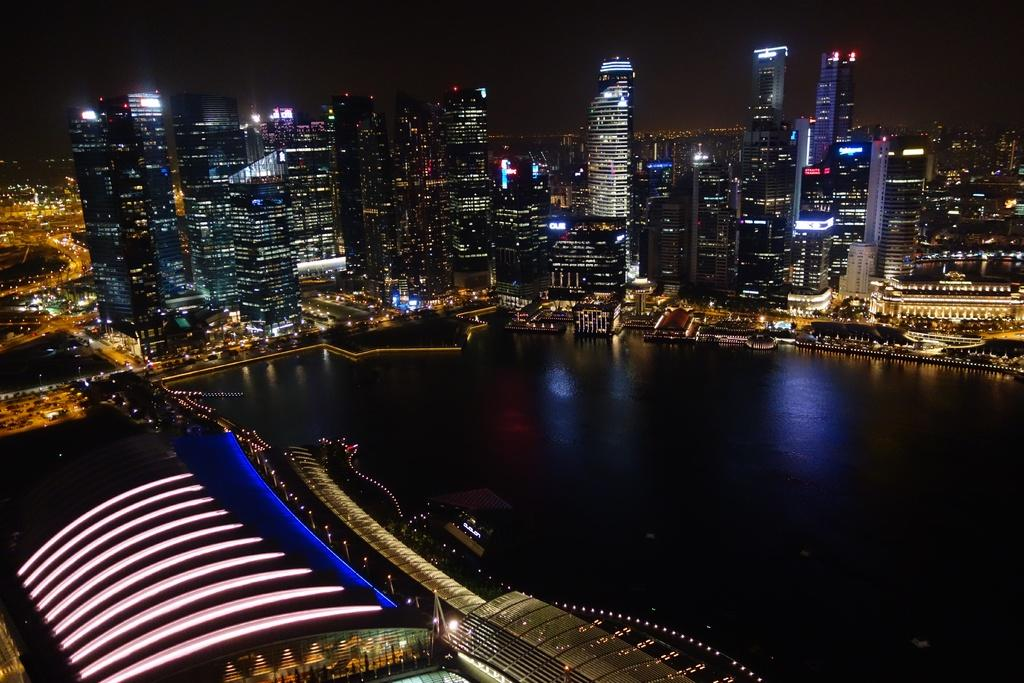What perspective is the image taken from? The image is taken from a top view. What type of structures can be seen in the image? There are many buildings and skyscrapers in the image. What can be seen to the left in the image? There are roads to the left in the image. What natural feature is present in the center of the image? There is water in the center of the image. What type of pancake is being served on the polish salt in the image? There is no pancake, polish, or salt present in the image. 